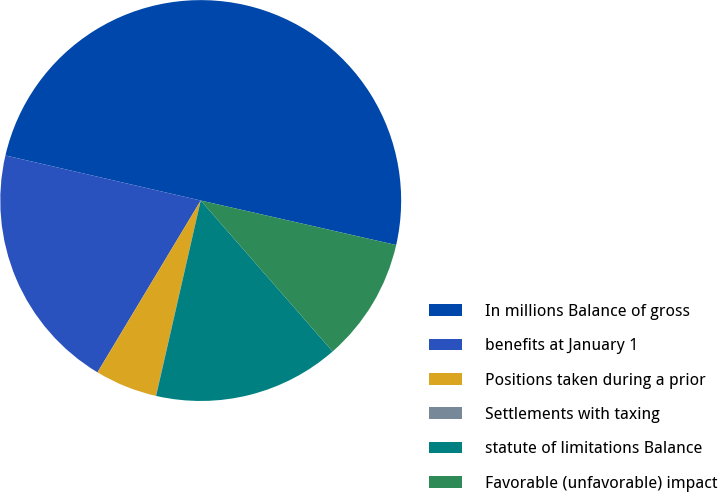Convert chart to OTSL. <chart><loc_0><loc_0><loc_500><loc_500><pie_chart><fcel>In millions Balance of gross<fcel>benefits at January 1<fcel>Positions taken during a prior<fcel>Settlements with taxing<fcel>statute of limitations Balance<fcel>Favorable (unfavorable) impact<nl><fcel>49.95%<fcel>20.0%<fcel>5.02%<fcel>0.02%<fcel>15.0%<fcel>10.01%<nl></chart> 